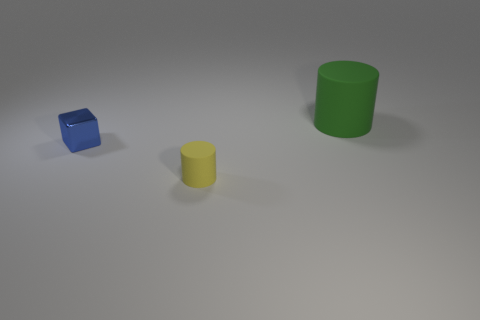Are there any other things that are the same shape as the metallic thing?
Give a very brief answer. No. Is there any other thing that is the same size as the green rubber object?
Ensure brevity in your answer.  No. How many cylinders are behind the cylinder that is in front of the big rubber thing?
Keep it short and to the point. 1. There is a large green matte thing; are there any objects left of it?
Offer a terse response. Yes. There is a object that is in front of the small thing that is behind the yellow matte cylinder; what is its shape?
Make the answer very short. Cylinder. Are there fewer big objects to the left of the small block than large green cylinders that are to the left of the big thing?
Offer a terse response. No. The tiny matte object that is the same shape as the large green rubber object is what color?
Your response must be concise. Yellow. What number of matte cylinders are both right of the tiny matte object and in front of the big rubber thing?
Give a very brief answer. 0. Are there more small blocks that are to the left of the small yellow rubber thing than blue metallic objects to the right of the big cylinder?
Your answer should be compact. Yes. What is the size of the blue metal object?
Make the answer very short. Small. 